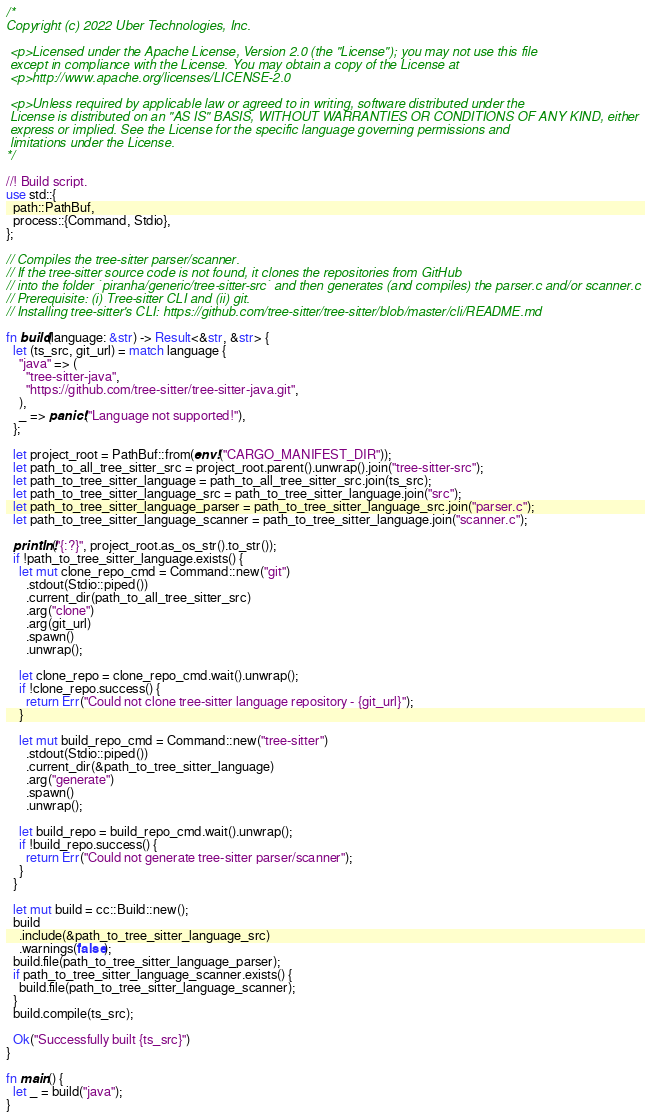Convert code to text. <code><loc_0><loc_0><loc_500><loc_500><_Rust_>/*
Copyright (c) 2022 Uber Technologies, Inc.

 <p>Licensed under the Apache License, Version 2.0 (the "License"); you may not use this file
 except in compliance with the License. You may obtain a copy of the License at
 <p>http://www.apache.org/licenses/LICENSE-2.0

 <p>Unless required by applicable law or agreed to in writing, software distributed under the
 License is distributed on an "AS IS" BASIS, WITHOUT WARRANTIES OR CONDITIONS OF ANY KIND, either
 express or implied. See the License for the specific language governing permissions and
 limitations under the License.
*/

//! Build script.
use std::{
  path::PathBuf,
  process::{Command, Stdio},
};

// Compiles the tree-sitter parser/scanner.
// If the tree-sitter source code is not found, it clones the repositories from GitHub
// into the folder `piranha/generic/tree-sitter-src` and then generates (and compiles) the parser.c and/or scanner.c
// Prerequisite: (i) Tree-sitter CLI and (ii) git.
// Installing tree-sitter's CLI: https://github.com/tree-sitter/tree-sitter/blob/master/cli/README.md

fn build(language: &str) -> Result<&str, &str> {
  let (ts_src, git_url) = match language {
    "java" => (
      "tree-sitter-java",
      "https://github.com/tree-sitter/tree-sitter-java.git",
    ),
    _ => panic!("Language not supported!"),
  };

  let project_root = PathBuf::from(env!("CARGO_MANIFEST_DIR"));
  let path_to_all_tree_sitter_src = project_root.parent().unwrap().join("tree-sitter-src");
  let path_to_tree_sitter_language = path_to_all_tree_sitter_src.join(ts_src);
  let path_to_tree_sitter_language_src = path_to_tree_sitter_language.join("src");
  let path_to_tree_sitter_language_parser = path_to_tree_sitter_language_src.join("parser.c");
  let path_to_tree_sitter_language_scanner = path_to_tree_sitter_language.join("scanner.c");

  println!("{:?}", project_root.as_os_str().to_str());
  if !path_to_tree_sitter_language.exists() {
    let mut clone_repo_cmd = Command::new("git")
      .stdout(Stdio::piped())
      .current_dir(path_to_all_tree_sitter_src)
      .arg("clone")
      .arg(git_url)
      .spawn()
      .unwrap();

    let clone_repo = clone_repo_cmd.wait().unwrap();
    if !clone_repo.success() {
      return Err("Could not clone tree-sitter language repository - {git_url}");
    }

    let mut build_repo_cmd = Command::new("tree-sitter")
      .stdout(Stdio::piped())
      .current_dir(&path_to_tree_sitter_language)
      .arg("generate")
      .spawn()
      .unwrap();

    let build_repo = build_repo_cmd.wait().unwrap();
    if !build_repo.success() {
      return Err("Could not generate tree-sitter parser/scanner");
    }
  }

  let mut build = cc::Build::new();
  build
    .include(&path_to_tree_sitter_language_src)
    .warnings(false);
  build.file(path_to_tree_sitter_language_parser);
  if path_to_tree_sitter_language_scanner.exists() {
    build.file(path_to_tree_sitter_language_scanner);
  }
  build.compile(ts_src);

  Ok("Successfully built {ts_src}")
}

fn main() {
  let _ = build("java");
}
</code> 